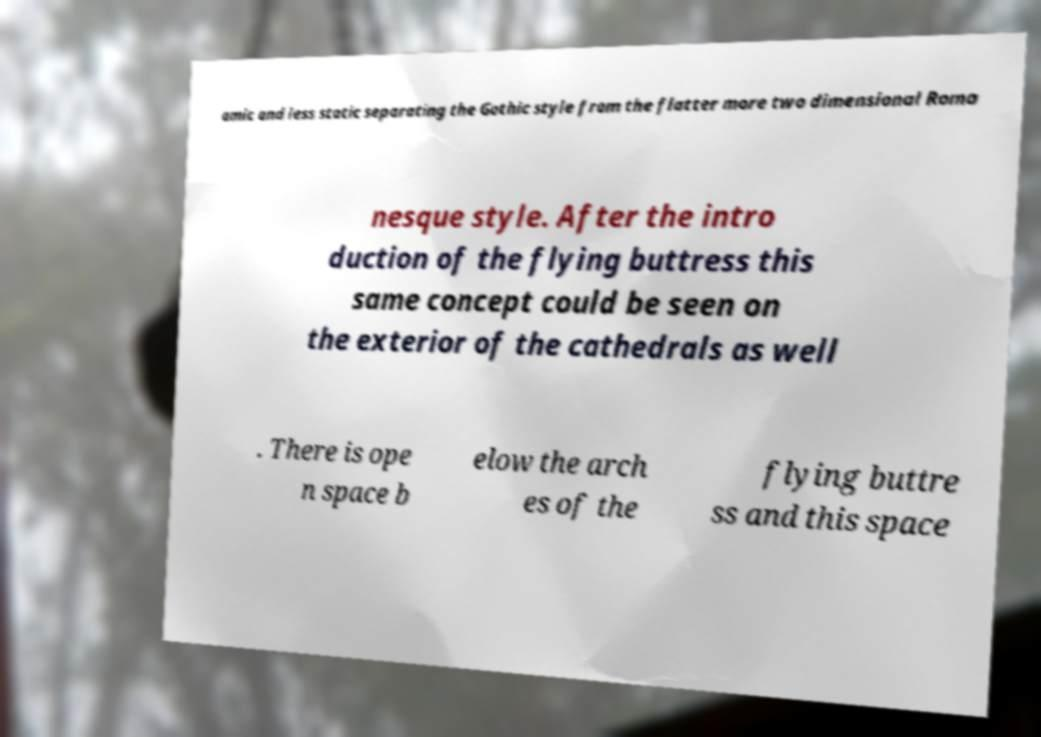Can you read and provide the text displayed in the image?This photo seems to have some interesting text. Can you extract and type it out for me? amic and less static separating the Gothic style from the flatter more two dimensional Roma nesque style. After the intro duction of the flying buttress this same concept could be seen on the exterior of the cathedrals as well . There is ope n space b elow the arch es of the flying buttre ss and this space 